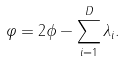Convert formula to latex. <formula><loc_0><loc_0><loc_500><loc_500>\varphi = 2 \phi - \sum _ { i = 1 } ^ { D } \lambda _ { i } .</formula> 